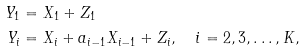Convert formula to latex. <formula><loc_0><loc_0><loc_500><loc_500>Y _ { 1 } & = X _ { 1 } + Z _ { 1 } \\ Y _ { i } & = X _ { i } + a _ { i - 1 } X _ { i - 1 } + Z _ { i } , \quad i = 2 , 3 , \dots , K ,</formula> 